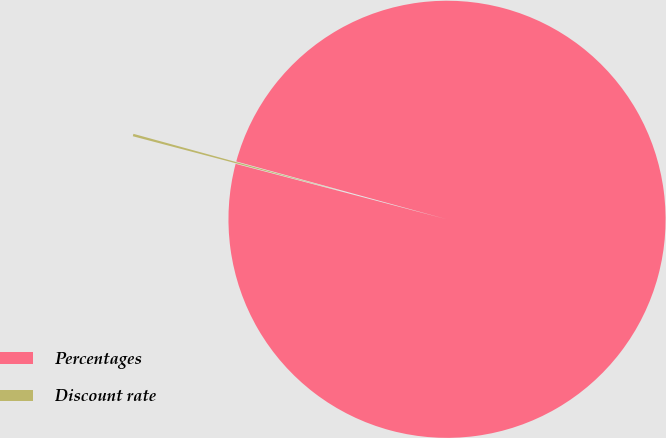Convert chart to OTSL. <chart><loc_0><loc_0><loc_500><loc_500><pie_chart><fcel>Percentages<fcel>Discount rate<nl><fcel>99.82%<fcel>0.18%<nl></chart> 